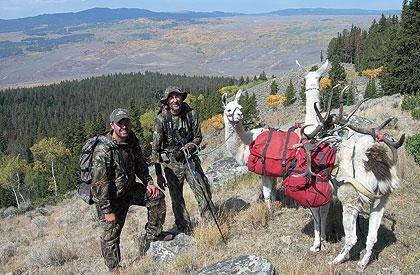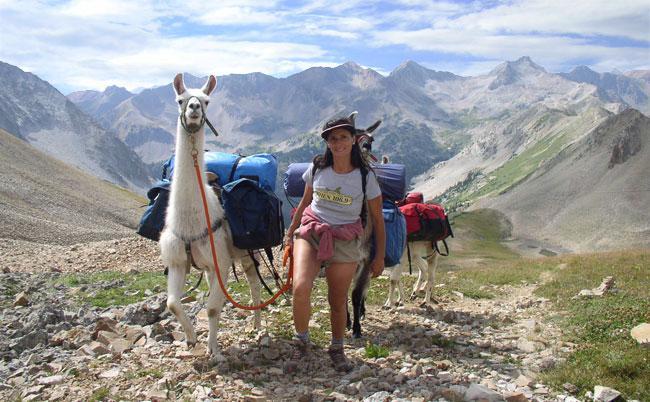The first image is the image on the left, the second image is the image on the right. Examine the images to the left and right. Is the description "One man in camo with a bow is leading no more than two packed llamas leftward in one image." accurate? Answer yes or no. No. 